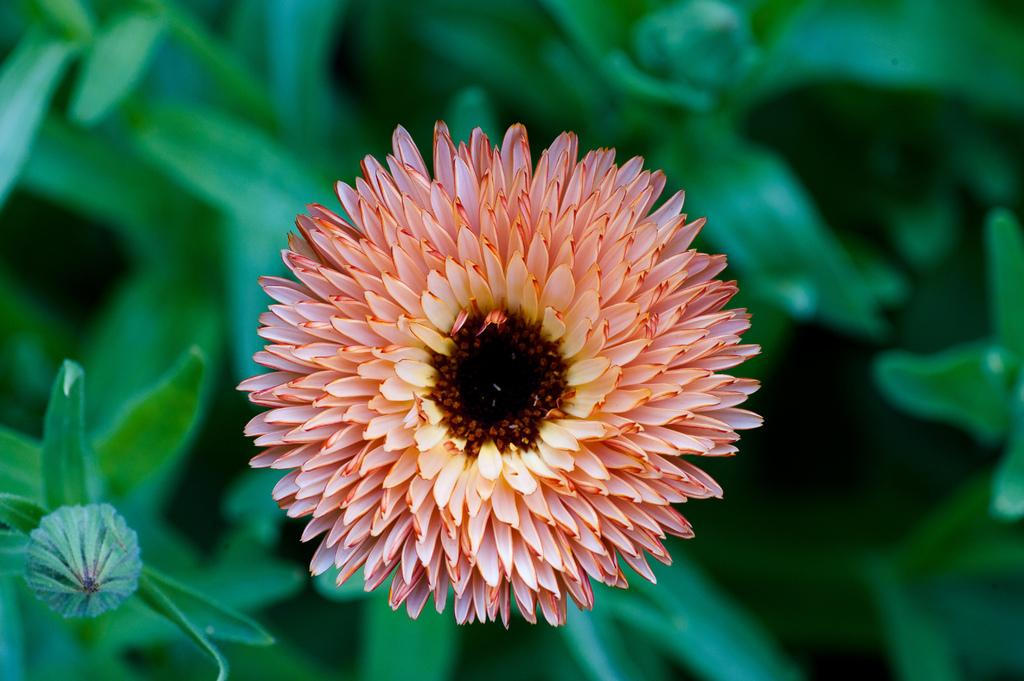What is the main subject of the image? There is a flower in the image. Can you describe the colors of the flower? The flower has pale red and pale yellow colors. Are there any other parts of the flower visible in the image? Yes, there are leaves associated with the flower. How many rings are visible on the flower in the image? There are no rings visible on the flower in the image. 